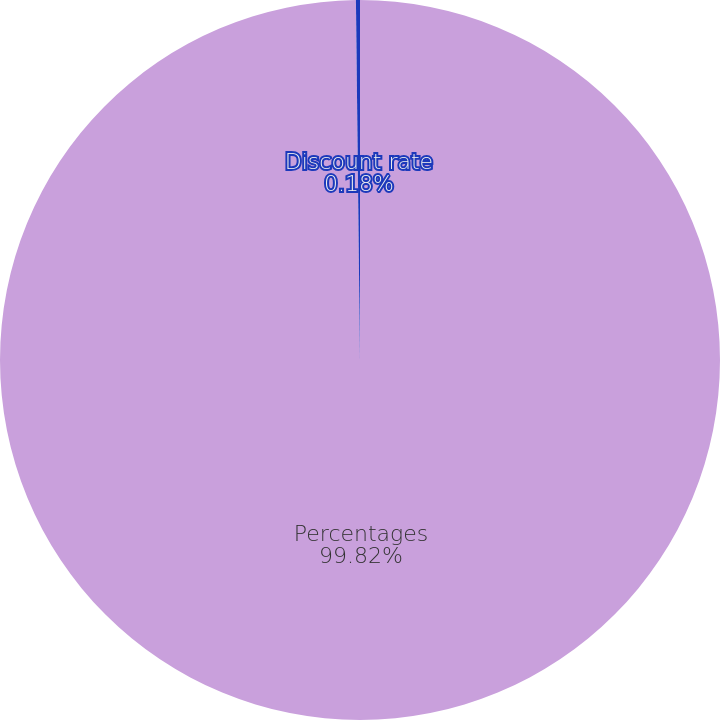<chart> <loc_0><loc_0><loc_500><loc_500><pie_chart><fcel>Percentages<fcel>Discount rate<nl><fcel>99.82%<fcel>0.18%<nl></chart> 